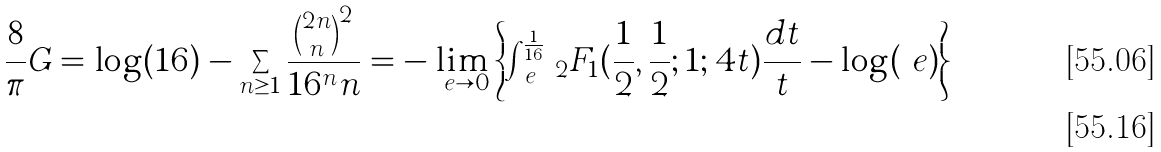<formula> <loc_0><loc_0><loc_500><loc_500>\frac { 8 } { \pi } G = \log ( 1 6 ) - \sum _ { n \geq 1 } \frac { \binom { 2 n } { n } ^ { 2 } } { 1 6 ^ { n } n } = - \lim _ { \ e \to 0 } \left \{ \int _ { \ e } ^ { \frac { 1 } { 1 6 } } \, _ { 2 } F _ { 1 } ( \frac { 1 } { 2 } , \frac { 1 } { 2 } ; 1 ; 4 t ) \frac { d t } { t } - \log ( \ e ) \right \} \\</formula> 